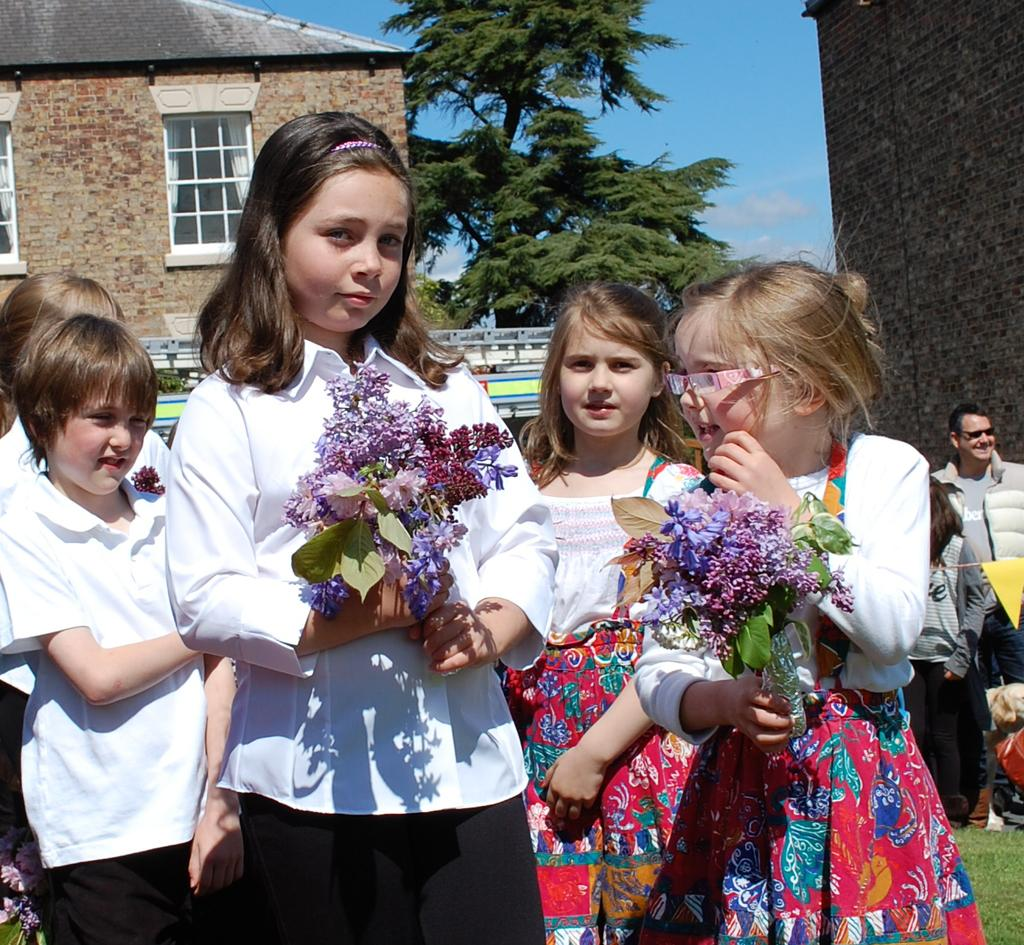Who or what is present in the image? There are people in the image. What type of vegetation can be seen in the image? There are flowers, grass, and trees in the image. What type of structure is visible in the image? There is a building in the image. What architectural feature can be seen on the building? There are windows in the image. What part of the natural environment is visible in the image? The sky is visible in the image. What is the income of the person holding the chalk in the image? There is no person holding chalk in the image, and therefore no income can be determined. How many feet are visible in the image? There are no feet visible in the image. 